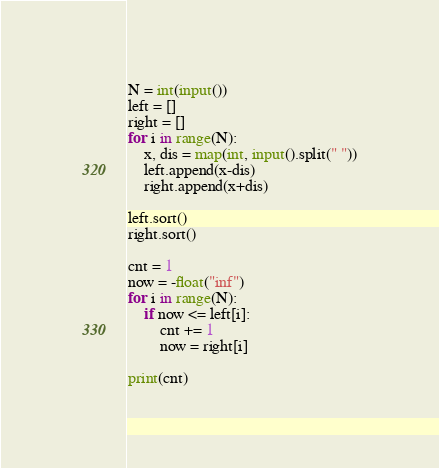<code> <loc_0><loc_0><loc_500><loc_500><_Python_>N = int(input())
left = [] 
right = []
for i in range(N):
    x, dis = map(int, input().split(" "))
    left.append(x-dis)
    right.append(x+dis)

left.sort()
right.sort()

cnt = 1
now = -float("inf")
for i in range(N):
    if now <= left[i]:
        cnt += 1
        now = right[i]

print(cnt)</code> 